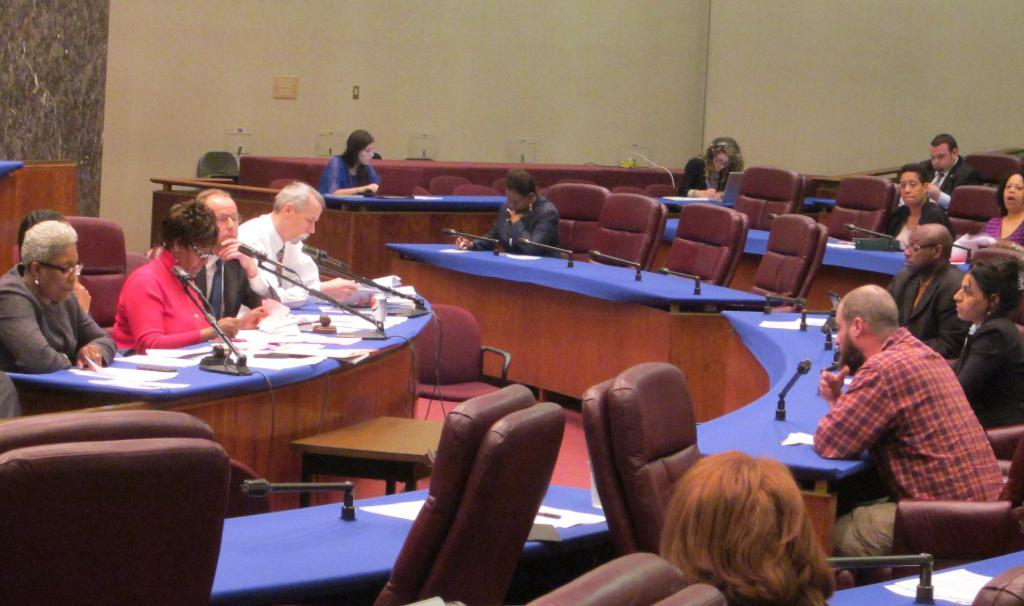What are the people in the image doing? The people in the image are sitting on chairs. What is in front of the people? There is a desk in front of the people. What can be seen in the background of the image? There is a wall visible in the background of the image. What type of turkey is being served on the desk in the image? There is no turkey present in the image; it only features people sitting on chairs and a desk in front of them. 